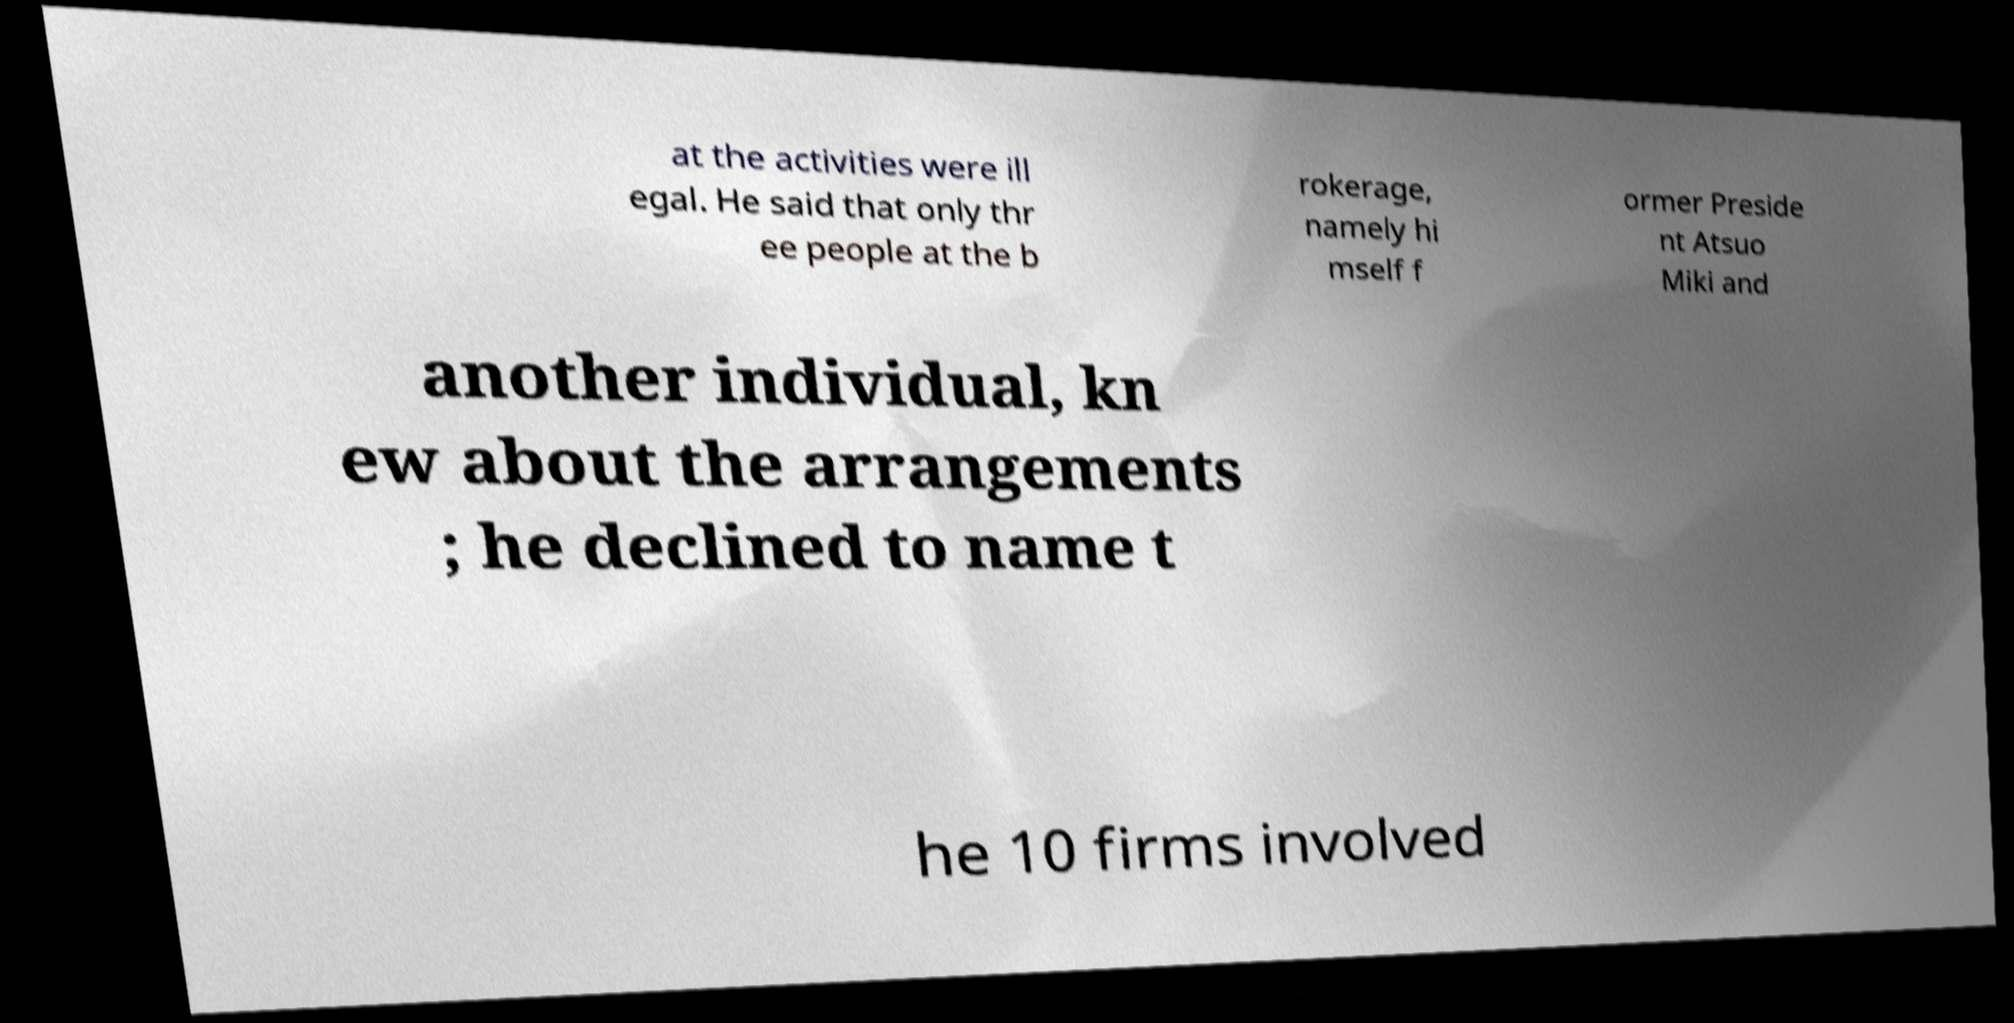Could you extract and type out the text from this image? at the activities were ill egal. He said that only thr ee people at the b rokerage, namely hi mself f ormer Preside nt Atsuo Miki and another individual, kn ew about the arrangements ; he declined to name t he 10 firms involved 